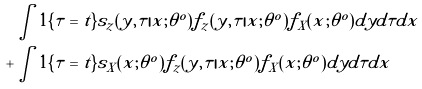<formula> <loc_0><loc_0><loc_500><loc_500>& \int 1 \{ \tau = t \} s _ { z } ( y , \tau | x ; \theta ^ { o } ) f _ { z } ( y , \tau | x ; \theta ^ { o } ) f _ { X } ( x ; \theta ^ { o } ) d y d \tau d x \\ + & \int 1 \{ \tau = t \} s _ { X } ( x ; \theta ^ { o } ) f _ { z } ( y , \tau | x ; \theta ^ { o } ) f _ { X } ( x ; \theta ^ { o } ) d y d \tau d x</formula> 